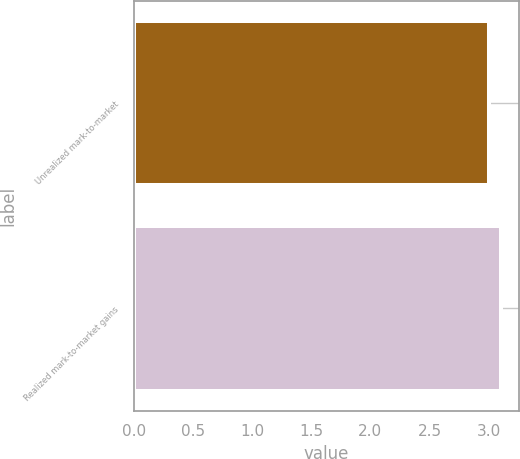Convert chart to OTSL. <chart><loc_0><loc_0><loc_500><loc_500><bar_chart><fcel>Unrealized mark-to-market<fcel>Realized mark-to-market gains<nl><fcel>3<fcel>3.1<nl></chart> 